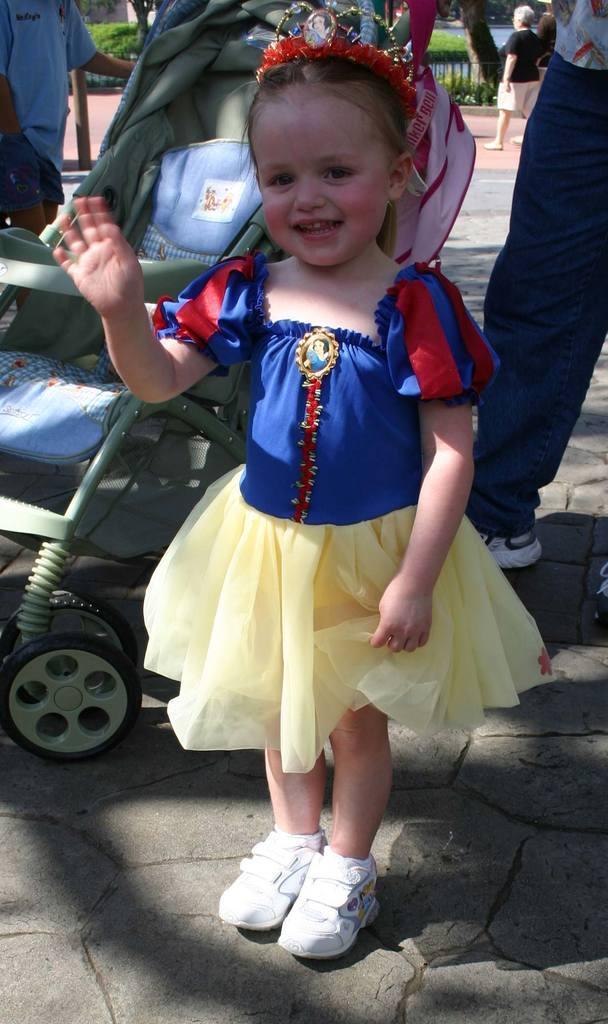Please provide a concise description of this image. In this image there are people, plants, baby, branches and girl. 